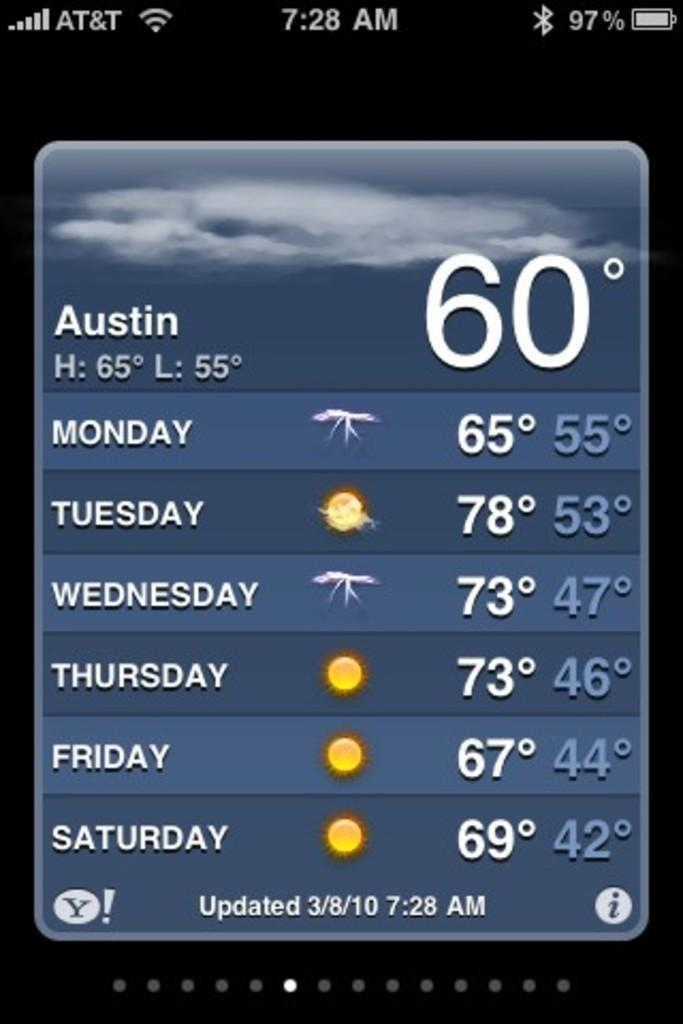<image>
Summarize the visual content of the image. A screen shot of a smartphone shows the weather in Austin. 